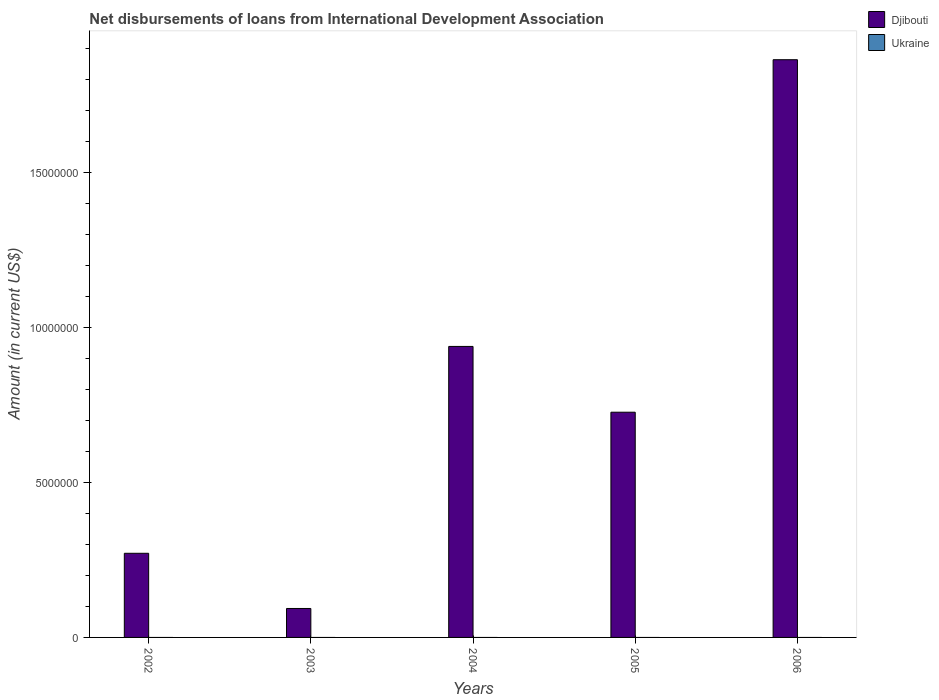How many different coloured bars are there?
Your answer should be compact. 1. Are the number of bars on each tick of the X-axis equal?
Keep it short and to the point. Yes. How many bars are there on the 2nd tick from the left?
Provide a succinct answer. 1. How many bars are there on the 5th tick from the right?
Give a very brief answer. 1. In how many cases, is the number of bars for a given year not equal to the number of legend labels?
Your answer should be very brief. 5. What is the amount of loans disbursed in Djibouti in 2002?
Offer a terse response. 2.71e+06. Across all years, what is the maximum amount of loans disbursed in Djibouti?
Offer a very short reply. 1.86e+07. Across all years, what is the minimum amount of loans disbursed in Djibouti?
Your answer should be very brief. 9.34e+05. What is the total amount of loans disbursed in Ukraine in the graph?
Offer a very short reply. 0. What is the difference between the amount of loans disbursed in Djibouti in 2004 and that in 2006?
Provide a short and direct response. -9.25e+06. What is the difference between the amount of loans disbursed in Djibouti in 2003 and the amount of loans disbursed in Ukraine in 2004?
Your answer should be very brief. 9.34e+05. In how many years, is the amount of loans disbursed in Djibouti greater than 4000000 US$?
Provide a succinct answer. 3. What is the ratio of the amount of loans disbursed in Djibouti in 2002 to that in 2006?
Your answer should be very brief. 0.15. What is the difference between the highest and the second highest amount of loans disbursed in Djibouti?
Offer a terse response. 9.25e+06. What is the difference between the highest and the lowest amount of loans disbursed in Djibouti?
Make the answer very short. 1.77e+07. In how many years, is the amount of loans disbursed in Ukraine greater than the average amount of loans disbursed in Ukraine taken over all years?
Ensure brevity in your answer.  0. What is the difference between two consecutive major ticks on the Y-axis?
Your answer should be very brief. 5.00e+06. How many legend labels are there?
Your response must be concise. 2. How are the legend labels stacked?
Keep it short and to the point. Vertical. What is the title of the graph?
Ensure brevity in your answer.  Net disbursements of loans from International Development Association. What is the Amount (in current US$) of Djibouti in 2002?
Give a very brief answer. 2.71e+06. What is the Amount (in current US$) of Ukraine in 2002?
Provide a short and direct response. 0. What is the Amount (in current US$) in Djibouti in 2003?
Offer a terse response. 9.34e+05. What is the Amount (in current US$) in Djibouti in 2004?
Make the answer very short. 9.39e+06. What is the Amount (in current US$) of Djibouti in 2005?
Provide a short and direct response. 7.26e+06. What is the Amount (in current US$) of Djibouti in 2006?
Provide a short and direct response. 1.86e+07. What is the Amount (in current US$) in Ukraine in 2006?
Provide a short and direct response. 0. Across all years, what is the maximum Amount (in current US$) in Djibouti?
Your response must be concise. 1.86e+07. Across all years, what is the minimum Amount (in current US$) of Djibouti?
Your answer should be compact. 9.34e+05. What is the total Amount (in current US$) in Djibouti in the graph?
Provide a short and direct response. 3.89e+07. What is the total Amount (in current US$) of Ukraine in the graph?
Make the answer very short. 0. What is the difference between the Amount (in current US$) of Djibouti in 2002 and that in 2003?
Keep it short and to the point. 1.78e+06. What is the difference between the Amount (in current US$) of Djibouti in 2002 and that in 2004?
Make the answer very short. -6.67e+06. What is the difference between the Amount (in current US$) of Djibouti in 2002 and that in 2005?
Keep it short and to the point. -4.55e+06. What is the difference between the Amount (in current US$) in Djibouti in 2002 and that in 2006?
Keep it short and to the point. -1.59e+07. What is the difference between the Amount (in current US$) of Djibouti in 2003 and that in 2004?
Offer a very short reply. -8.45e+06. What is the difference between the Amount (in current US$) in Djibouti in 2003 and that in 2005?
Your answer should be very brief. -6.33e+06. What is the difference between the Amount (in current US$) of Djibouti in 2003 and that in 2006?
Ensure brevity in your answer.  -1.77e+07. What is the difference between the Amount (in current US$) of Djibouti in 2004 and that in 2005?
Offer a very short reply. 2.12e+06. What is the difference between the Amount (in current US$) in Djibouti in 2004 and that in 2006?
Provide a succinct answer. -9.25e+06. What is the difference between the Amount (in current US$) in Djibouti in 2005 and that in 2006?
Your answer should be very brief. -1.14e+07. What is the average Amount (in current US$) in Djibouti per year?
Give a very brief answer. 7.79e+06. What is the ratio of the Amount (in current US$) of Djibouti in 2002 to that in 2003?
Your answer should be compact. 2.91. What is the ratio of the Amount (in current US$) in Djibouti in 2002 to that in 2004?
Your answer should be very brief. 0.29. What is the ratio of the Amount (in current US$) of Djibouti in 2002 to that in 2005?
Provide a succinct answer. 0.37. What is the ratio of the Amount (in current US$) in Djibouti in 2002 to that in 2006?
Your answer should be compact. 0.15. What is the ratio of the Amount (in current US$) of Djibouti in 2003 to that in 2004?
Ensure brevity in your answer.  0.1. What is the ratio of the Amount (in current US$) in Djibouti in 2003 to that in 2005?
Make the answer very short. 0.13. What is the ratio of the Amount (in current US$) in Djibouti in 2003 to that in 2006?
Offer a terse response. 0.05. What is the ratio of the Amount (in current US$) in Djibouti in 2004 to that in 2005?
Your answer should be compact. 1.29. What is the ratio of the Amount (in current US$) in Djibouti in 2004 to that in 2006?
Keep it short and to the point. 0.5. What is the ratio of the Amount (in current US$) of Djibouti in 2005 to that in 2006?
Your response must be concise. 0.39. What is the difference between the highest and the second highest Amount (in current US$) of Djibouti?
Your response must be concise. 9.25e+06. What is the difference between the highest and the lowest Amount (in current US$) of Djibouti?
Offer a very short reply. 1.77e+07. 